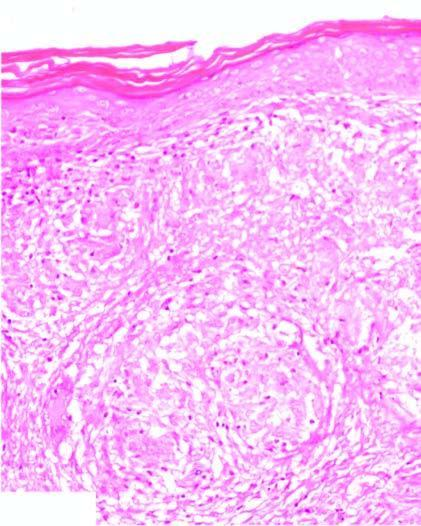what shows noncaseating epithelioid granulomas having langhans ' giant cells and paucity of lymphocytes, termed as naked granulomas?
Answer the question using a single word or phrase. Dermis 